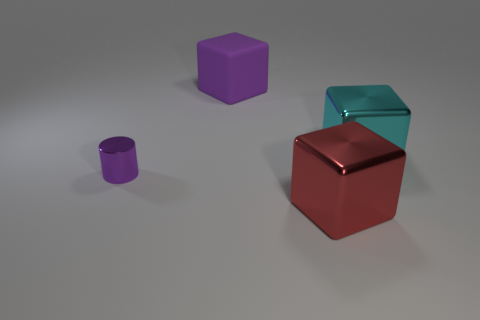Subtract all metallic blocks. How many blocks are left? 1 Add 4 large metal spheres. How many objects exist? 8 Subtract all purple cubes. How many cubes are left? 2 Subtract 2 cubes. How many cubes are left? 1 Subtract all cubes. How many objects are left? 1 Subtract all yellow blocks. Subtract all yellow cylinders. How many blocks are left? 3 Subtract 0 yellow cylinders. How many objects are left? 4 Subtract all big blue metal cubes. Subtract all tiny purple things. How many objects are left? 3 Add 3 small purple shiny cylinders. How many small purple shiny cylinders are left? 4 Add 1 tiny green matte cylinders. How many tiny green matte cylinders exist? 1 